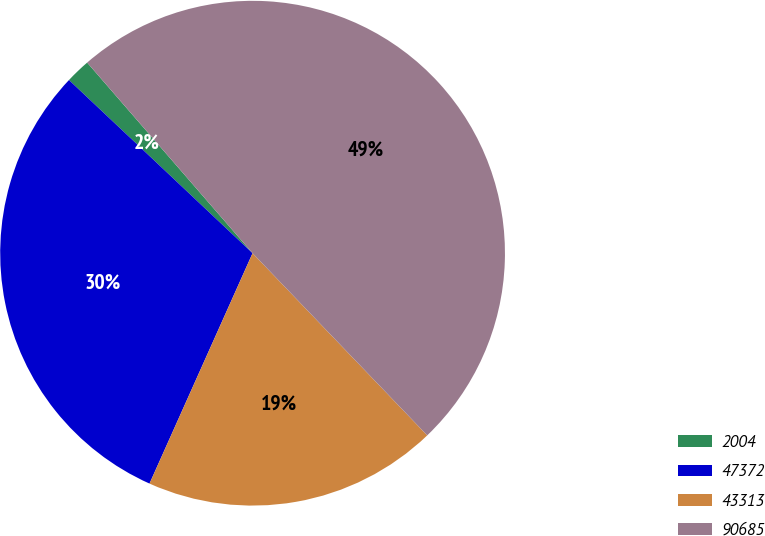Convert chart. <chart><loc_0><loc_0><loc_500><loc_500><pie_chart><fcel>2004<fcel>47372<fcel>43313<fcel>90685<nl><fcel>1.59%<fcel>30.34%<fcel>18.86%<fcel>49.21%<nl></chart> 